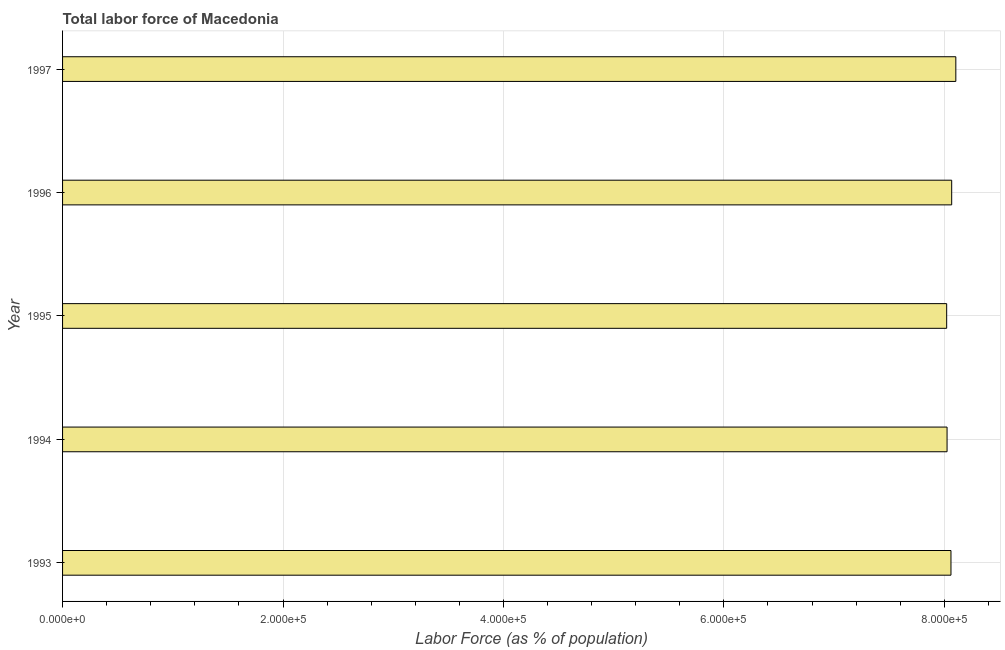What is the title of the graph?
Offer a terse response. Total labor force of Macedonia. What is the label or title of the X-axis?
Offer a very short reply. Labor Force (as % of population). What is the label or title of the Y-axis?
Give a very brief answer. Year. What is the total labor force in 1993?
Your response must be concise. 8.06e+05. Across all years, what is the maximum total labor force?
Offer a terse response. 8.10e+05. Across all years, what is the minimum total labor force?
Keep it short and to the point. 8.02e+05. In which year was the total labor force minimum?
Provide a short and direct response. 1995. What is the sum of the total labor force?
Keep it short and to the point. 4.03e+06. What is the difference between the total labor force in 1995 and 1997?
Offer a very short reply. -8304. What is the average total labor force per year?
Keep it short and to the point. 8.06e+05. What is the median total labor force?
Your answer should be very brief. 8.06e+05. Do a majority of the years between 1994 and 1997 (inclusive) have total labor force greater than 560000 %?
Provide a succinct answer. Yes. Is the difference between the total labor force in 1996 and 1997 greater than the difference between any two years?
Give a very brief answer. No. What is the difference between the highest and the second highest total labor force?
Your answer should be compact. 3760. Is the sum of the total labor force in 1994 and 1997 greater than the maximum total labor force across all years?
Make the answer very short. Yes. What is the difference between the highest and the lowest total labor force?
Give a very brief answer. 8304. In how many years, is the total labor force greater than the average total labor force taken over all years?
Offer a terse response. 3. How many bars are there?
Offer a very short reply. 5. What is the difference between two consecutive major ticks on the X-axis?
Offer a very short reply. 2.00e+05. What is the Labor Force (as % of population) in 1993?
Your response must be concise. 8.06e+05. What is the Labor Force (as % of population) in 1994?
Offer a very short reply. 8.02e+05. What is the Labor Force (as % of population) of 1995?
Your answer should be compact. 8.02e+05. What is the Labor Force (as % of population) in 1996?
Your response must be concise. 8.07e+05. What is the Labor Force (as % of population) in 1997?
Your response must be concise. 8.10e+05. What is the difference between the Labor Force (as % of population) in 1993 and 1994?
Provide a succinct answer. 3540. What is the difference between the Labor Force (as % of population) in 1993 and 1995?
Give a very brief answer. 3891. What is the difference between the Labor Force (as % of population) in 1993 and 1996?
Make the answer very short. -653. What is the difference between the Labor Force (as % of population) in 1993 and 1997?
Your answer should be very brief. -4413. What is the difference between the Labor Force (as % of population) in 1994 and 1995?
Your answer should be compact. 351. What is the difference between the Labor Force (as % of population) in 1994 and 1996?
Your answer should be very brief. -4193. What is the difference between the Labor Force (as % of population) in 1994 and 1997?
Your answer should be compact. -7953. What is the difference between the Labor Force (as % of population) in 1995 and 1996?
Your response must be concise. -4544. What is the difference between the Labor Force (as % of population) in 1995 and 1997?
Offer a very short reply. -8304. What is the difference between the Labor Force (as % of population) in 1996 and 1997?
Ensure brevity in your answer.  -3760. What is the ratio of the Labor Force (as % of population) in 1993 to that in 1996?
Provide a short and direct response. 1. What is the ratio of the Labor Force (as % of population) in 1995 to that in 1996?
Your response must be concise. 0.99. 